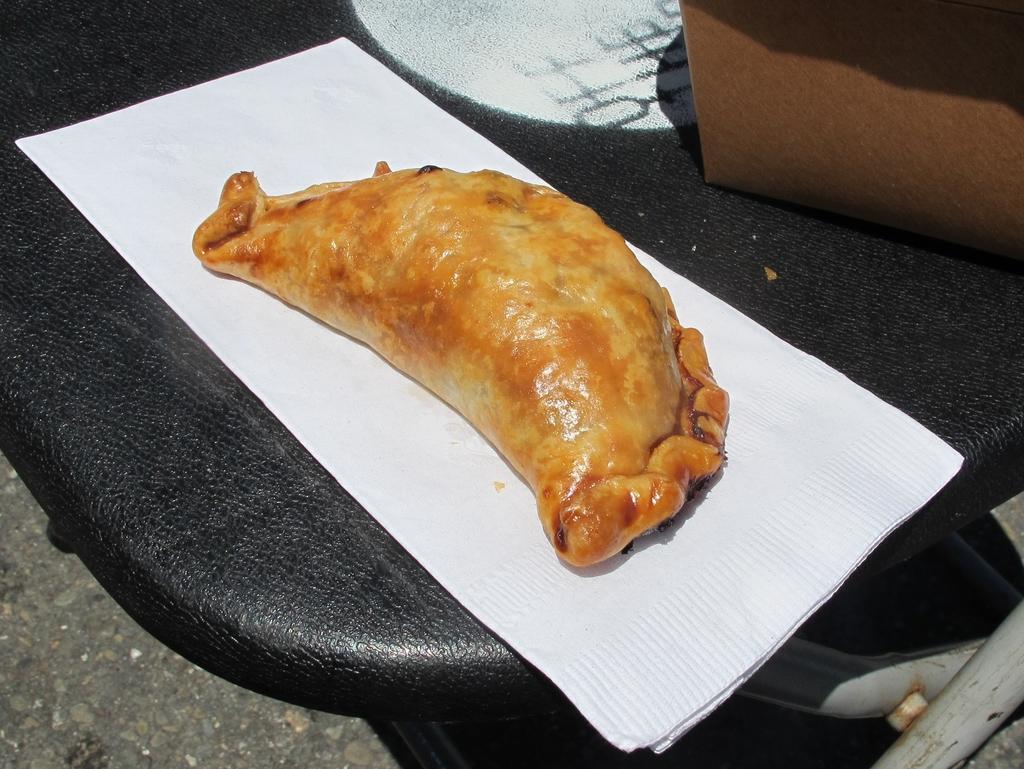Can you describe this image briefly? The picture consists of a table, on the table there are tissue, food item and a box. At the bottom it is floor. It is sunny. 